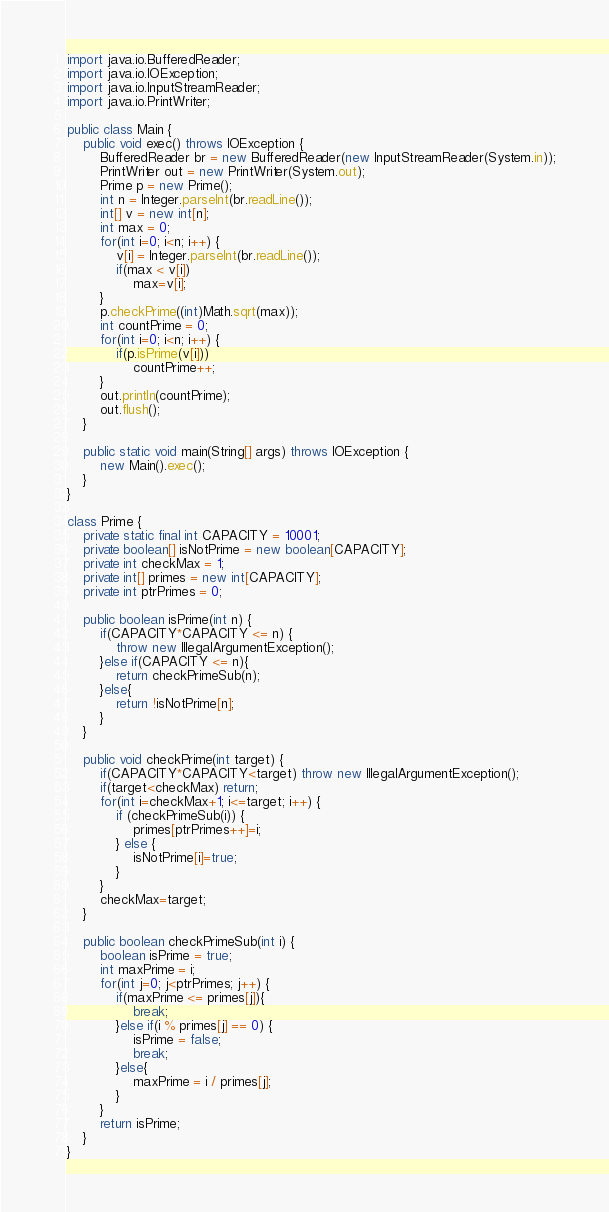<code> <loc_0><loc_0><loc_500><loc_500><_Java_>import java.io.BufferedReader;
import java.io.IOException;
import java.io.InputStreamReader;
import java.io.PrintWriter;
 
public class Main {
	public void exec() throws IOException {
        BufferedReader br = new BufferedReader(new InputStreamReader(System.in));
        PrintWriter out = new PrintWriter(System.out);
        Prime p = new Prime();
        int n = Integer.parseInt(br.readLine());
        int[] v = new int[n];
        int max = 0;
        for(int i=0; i<n; i++) {
        	v[i] = Integer.parseInt(br.readLine());
        	if(max < v[i])
        		max=v[i];
        }
        p.checkPrime((int)Math.sqrt(max));
        int countPrime = 0;
        for(int i=0; i<n; i++) {
        	if(p.isPrime(v[i]))
        		countPrime++;
        }
        out.println(countPrime);
        out.flush();
    }

    public static void main(String[] args) throws IOException {
        new Main().exec();
    }
}

class Prime {
	private static final int CAPACITY = 10001;
	private boolean[] isNotPrime = new boolean[CAPACITY];
	private int checkMax = 1;
	private int[] primes = new int[CAPACITY];
	private int ptrPrimes = 0;
	
	public boolean isPrime(int n) {
		if(CAPACITY*CAPACITY <= n) {
			throw new IllegalArgumentException();
		}else if(CAPACITY <= n){
			return checkPrimeSub(n);
		}else{
			return !isNotPrime[n];
		}
	}
	
	public void checkPrime(int target) {
		if(CAPACITY*CAPACITY<target) throw new IllegalArgumentException();
		if(target<checkMax) return;
		for(int i=checkMax+1; i<=target; i++) {
			if (checkPrimeSub(i)) {
				primes[ptrPrimes++]=i;
			} else {
				isNotPrime[i]=true;
			}
		}
		checkMax=target;
	}
	
	public boolean checkPrimeSub(int i) {
		boolean isPrime = true;
		int maxPrime = i;
		for(int j=0; j<ptrPrimes; j++) {
			if(maxPrime <= primes[j]){
				break;
			}else if(i % primes[j] == 0) {
				isPrime = false;
				break;
			}else{
				maxPrime = i / primes[j];
			}
		}
		return isPrime;
	}
}</code> 